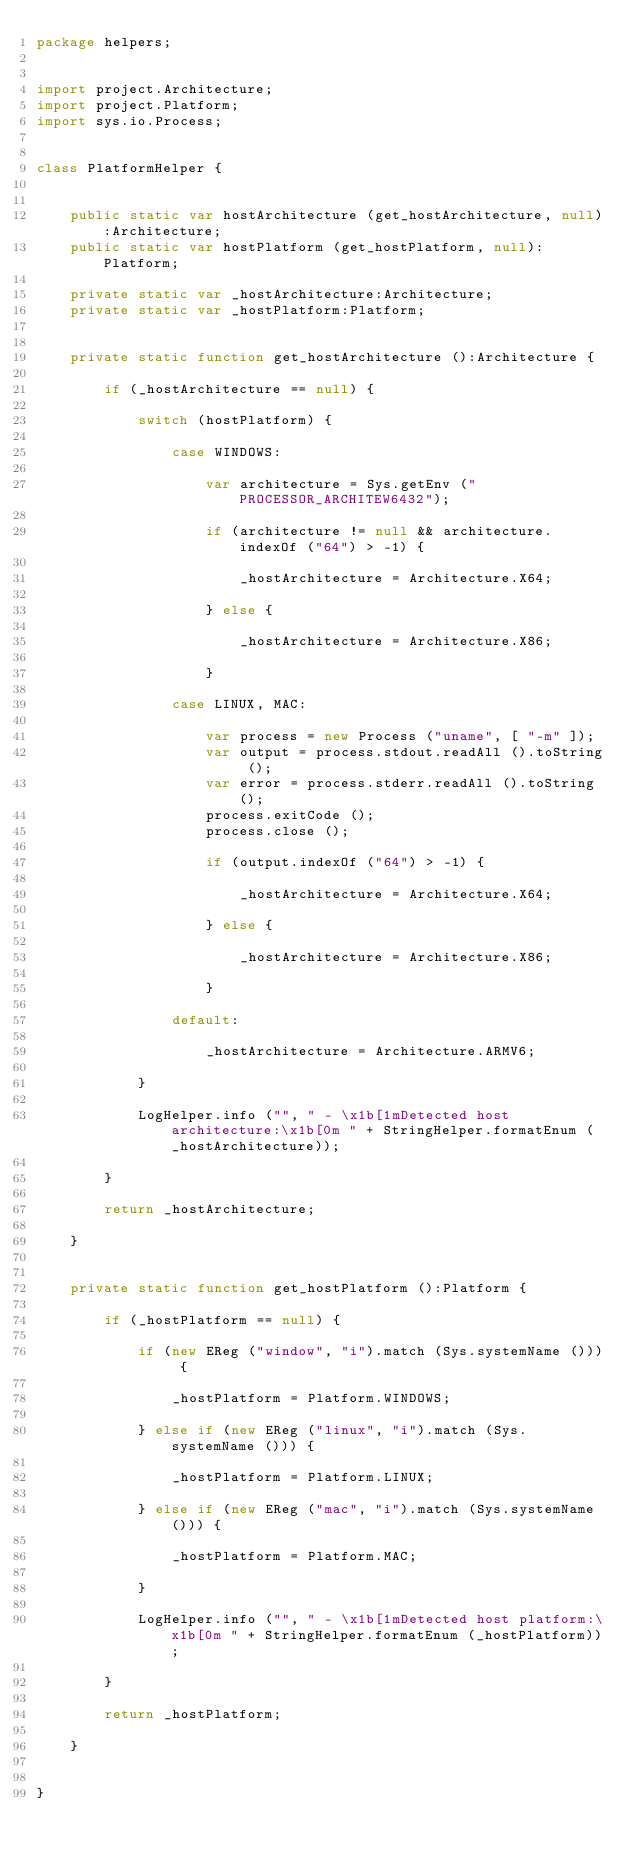<code> <loc_0><loc_0><loc_500><loc_500><_Haxe_>package helpers;


import project.Architecture;
import project.Platform;
import sys.io.Process;


class PlatformHelper {
	
	
	public static var hostArchitecture (get_hostArchitecture, null):Architecture;
	public static var hostPlatform (get_hostPlatform, null):Platform;
	
	private static var _hostArchitecture:Architecture;
	private static var _hostPlatform:Platform;
	
	
	private static function get_hostArchitecture ():Architecture {
		
		if (_hostArchitecture == null) {
			
			switch (hostPlatform) {
				
				case WINDOWS:
					
					var architecture = Sys.getEnv ("PROCESSOR_ARCHITEW6432");
					
					if (architecture != null && architecture.indexOf ("64") > -1) {
						
						_hostArchitecture = Architecture.X64;
						
					} else {
						
						_hostArchitecture = Architecture.X86;
						
					}
					
				case LINUX, MAC:
					
					var process = new Process ("uname", [ "-m" ]);
					var output = process.stdout.readAll ().toString ();
					var error = process.stderr.readAll ().toString ();
					process.exitCode ();
					process.close ();
					
					if (output.indexOf ("64") > -1) {
						
						_hostArchitecture = Architecture.X64;
						
					} else {
						
						_hostArchitecture = Architecture.X86;
						
					}
					
				default:
					
					_hostArchitecture = Architecture.ARMV6;
				
			}
			
			LogHelper.info ("", " - \x1b[1mDetected host architecture:\x1b[0m " + StringHelper.formatEnum (_hostArchitecture));
			
		}
		
		return _hostArchitecture;
		
	}
	
	
	private static function get_hostPlatform ():Platform {
		
		if (_hostPlatform == null) {
			
			if (new EReg ("window", "i").match (Sys.systemName ())) {
				
				_hostPlatform = Platform.WINDOWS;
				
			} else if (new EReg ("linux", "i").match (Sys.systemName ())) {
				
				_hostPlatform = Platform.LINUX;
				
			} else if (new EReg ("mac", "i").match (Sys.systemName ())) {
				
				_hostPlatform = Platform.MAC;
				
			}
			
			LogHelper.info ("", " - \x1b[1mDetected host platform:\x1b[0m " + StringHelper.formatEnum (_hostPlatform));
			
		}
		
		return _hostPlatform;
		
	}
		

}
</code> 